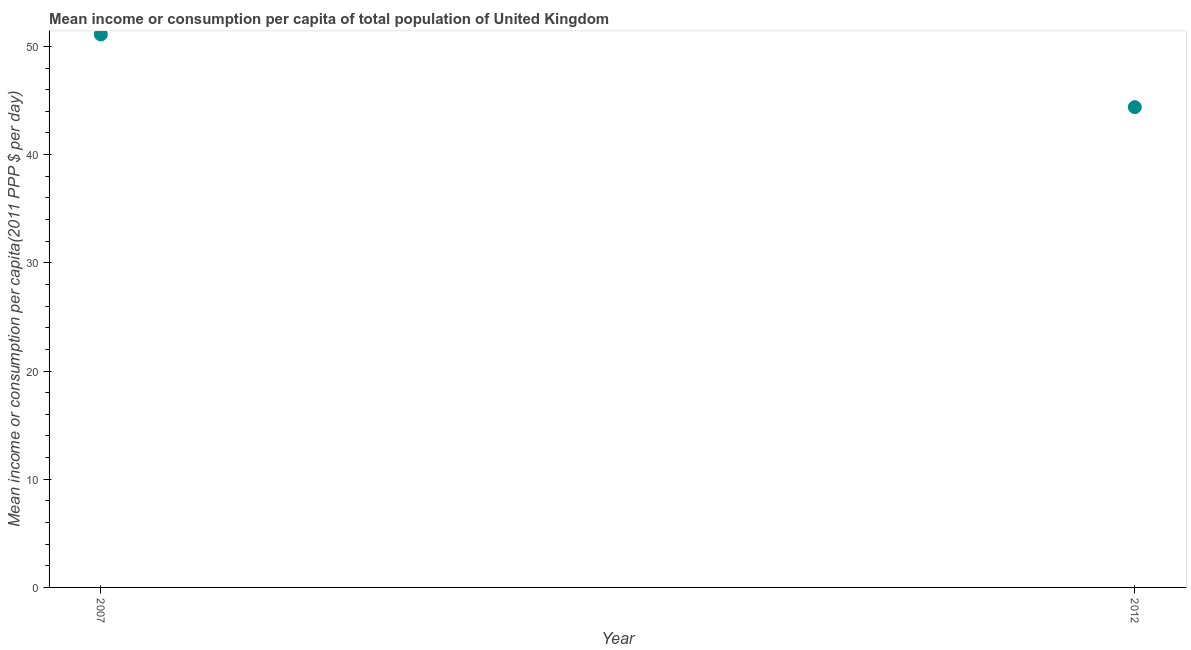What is the mean income or consumption in 2012?
Keep it short and to the point. 44.38. Across all years, what is the maximum mean income or consumption?
Your answer should be very brief. 51.1. Across all years, what is the minimum mean income or consumption?
Make the answer very short. 44.38. In which year was the mean income or consumption minimum?
Keep it short and to the point. 2012. What is the sum of the mean income or consumption?
Provide a short and direct response. 95.49. What is the difference between the mean income or consumption in 2007 and 2012?
Offer a terse response. 6.72. What is the average mean income or consumption per year?
Make the answer very short. 47.74. What is the median mean income or consumption?
Give a very brief answer. 47.74. What is the ratio of the mean income or consumption in 2007 to that in 2012?
Keep it short and to the point. 1.15. Is the mean income or consumption in 2007 less than that in 2012?
Keep it short and to the point. No. In how many years, is the mean income or consumption greater than the average mean income or consumption taken over all years?
Ensure brevity in your answer.  1. Does the mean income or consumption monotonically increase over the years?
Ensure brevity in your answer.  No. How many years are there in the graph?
Make the answer very short. 2. What is the difference between two consecutive major ticks on the Y-axis?
Offer a very short reply. 10. Are the values on the major ticks of Y-axis written in scientific E-notation?
Give a very brief answer. No. What is the title of the graph?
Keep it short and to the point. Mean income or consumption per capita of total population of United Kingdom. What is the label or title of the Y-axis?
Offer a terse response. Mean income or consumption per capita(2011 PPP $ per day). What is the Mean income or consumption per capita(2011 PPP $ per day) in 2007?
Offer a terse response. 51.1. What is the Mean income or consumption per capita(2011 PPP $ per day) in 2012?
Provide a succinct answer. 44.38. What is the difference between the Mean income or consumption per capita(2011 PPP $ per day) in 2007 and 2012?
Ensure brevity in your answer.  6.72. What is the ratio of the Mean income or consumption per capita(2011 PPP $ per day) in 2007 to that in 2012?
Offer a terse response. 1.15. 